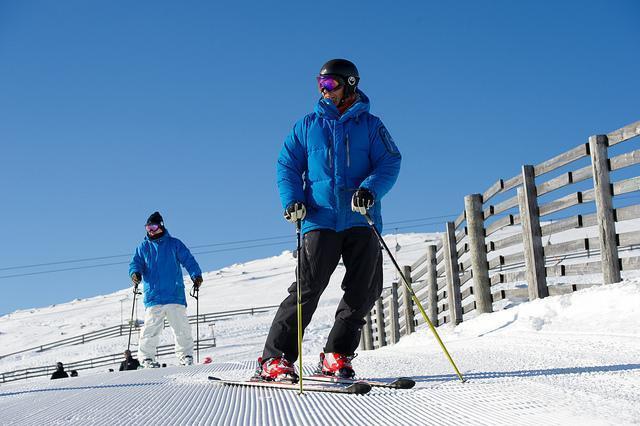How many people are there?
Give a very brief answer. 2. 